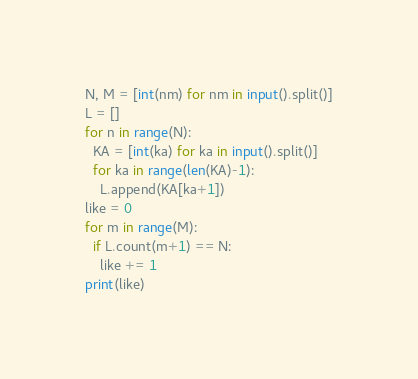Convert code to text. <code><loc_0><loc_0><loc_500><loc_500><_Python_>N, M = [int(nm) for nm in input().split()]
L = []
for n in range(N):
  KA = [int(ka) for ka in input().split()]
  for ka in range(len(KA)-1):
    L.append(KA[ka+1])
like = 0
for m in range(M):
  if L.count(m+1) == N:
    like += 1
print(like)</code> 